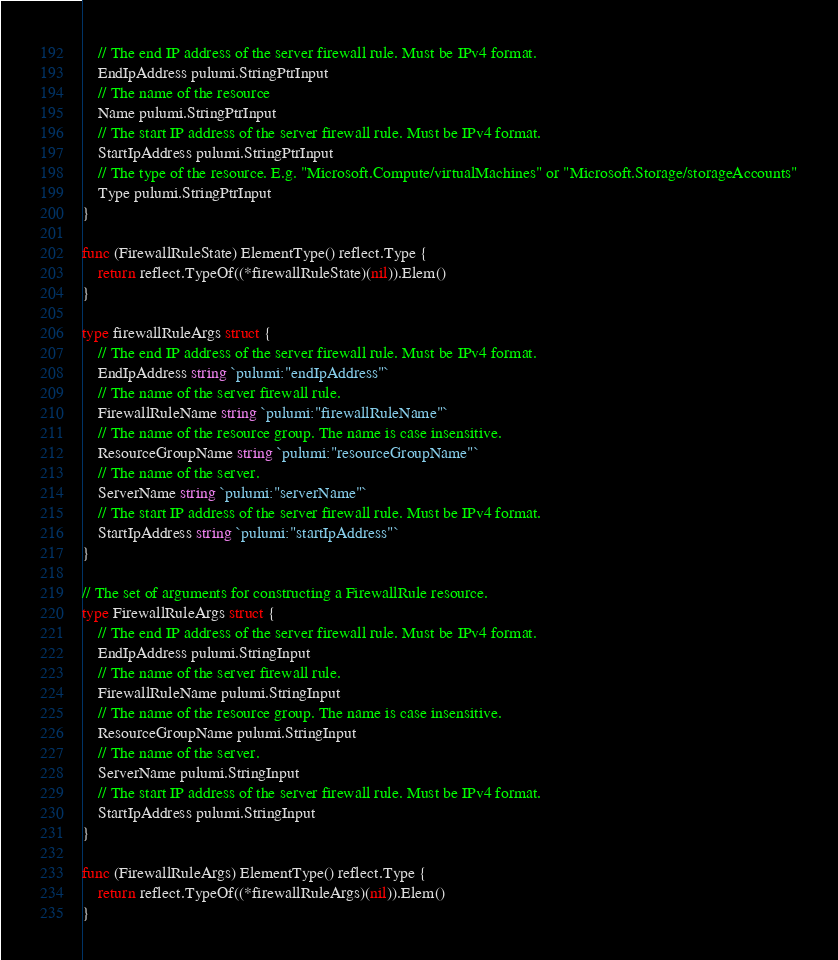<code> <loc_0><loc_0><loc_500><loc_500><_Go_>	// The end IP address of the server firewall rule. Must be IPv4 format.
	EndIpAddress pulumi.StringPtrInput
	// The name of the resource
	Name pulumi.StringPtrInput
	// The start IP address of the server firewall rule. Must be IPv4 format.
	StartIpAddress pulumi.StringPtrInput
	// The type of the resource. E.g. "Microsoft.Compute/virtualMachines" or "Microsoft.Storage/storageAccounts"
	Type pulumi.StringPtrInput
}

func (FirewallRuleState) ElementType() reflect.Type {
	return reflect.TypeOf((*firewallRuleState)(nil)).Elem()
}

type firewallRuleArgs struct {
	// The end IP address of the server firewall rule. Must be IPv4 format.
	EndIpAddress string `pulumi:"endIpAddress"`
	// The name of the server firewall rule.
	FirewallRuleName string `pulumi:"firewallRuleName"`
	// The name of the resource group. The name is case insensitive.
	ResourceGroupName string `pulumi:"resourceGroupName"`
	// The name of the server.
	ServerName string `pulumi:"serverName"`
	// The start IP address of the server firewall rule. Must be IPv4 format.
	StartIpAddress string `pulumi:"startIpAddress"`
}

// The set of arguments for constructing a FirewallRule resource.
type FirewallRuleArgs struct {
	// The end IP address of the server firewall rule. Must be IPv4 format.
	EndIpAddress pulumi.StringInput
	// The name of the server firewall rule.
	FirewallRuleName pulumi.StringInput
	// The name of the resource group. The name is case insensitive.
	ResourceGroupName pulumi.StringInput
	// The name of the server.
	ServerName pulumi.StringInput
	// The start IP address of the server firewall rule. Must be IPv4 format.
	StartIpAddress pulumi.StringInput
}

func (FirewallRuleArgs) ElementType() reflect.Type {
	return reflect.TypeOf((*firewallRuleArgs)(nil)).Elem()
}
</code> 